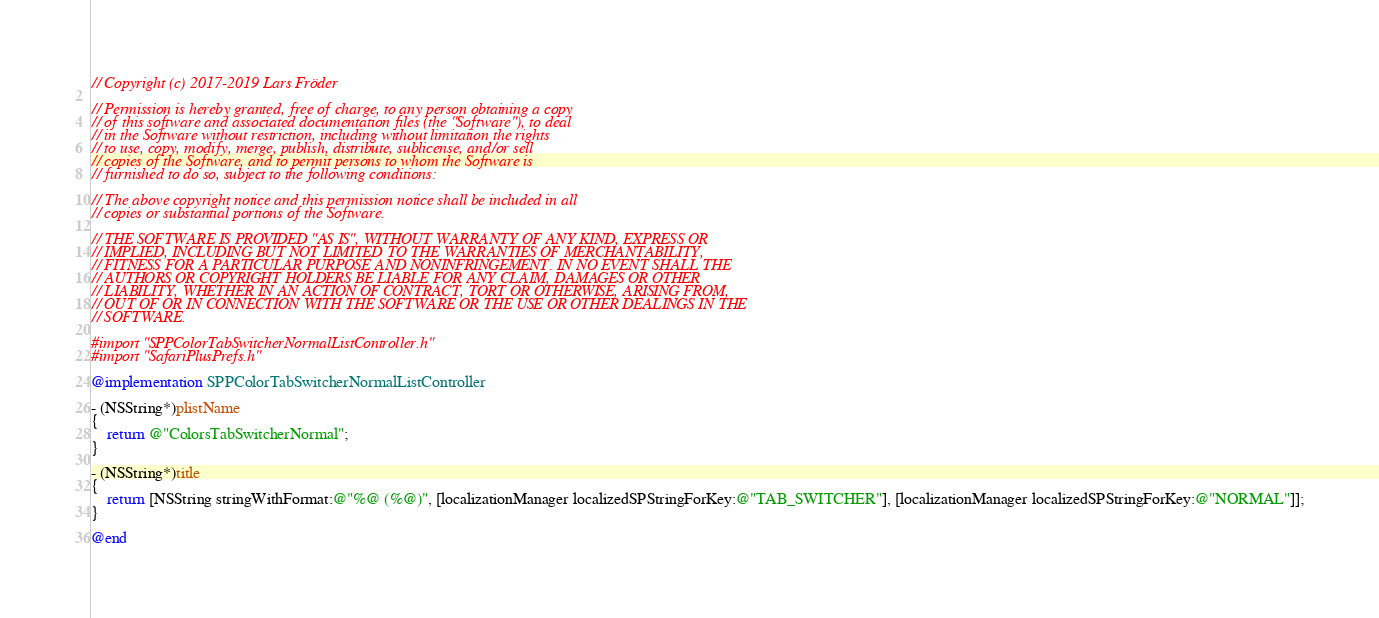Convert code to text. <code><loc_0><loc_0><loc_500><loc_500><_ObjectiveC_>// Copyright (c) 2017-2019 Lars Fröder

// Permission is hereby granted, free of charge, to any person obtaining a copy
// of this software and associated documentation files (the "Software"), to deal
// in the Software without restriction, including without limitation the rights
// to use, copy, modify, merge, publish, distribute, sublicense, and/or sell
// copies of the Software, and to permit persons to whom the Software is
// furnished to do so, subject to the following conditions:

// The above copyright notice and this permission notice shall be included in all
// copies or substantial portions of the Software.

// THE SOFTWARE IS PROVIDED "AS IS", WITHOUT WARRANTY OF ANY KIND, EXPRESS OR
// IMPLIED, INCLUDING BUT NOT LIMITED TO THE WARRANTIES OF MERCHANTABILITY,
// FITNESS FOR A PARTICULAR PURPOSE AND NONINFRINGEMENT. IN NO EVENT SHALL THE
// AUTHORS OR COPYRIGHT HOLDERS BE LIABLE FOR ANY CLAIM, DAMAGES OR OTHER
// LIABILITY, WHETHER IN AN ACTION OF CONTRACT, TORT OR OTHERWISE, ARISING FROM,
// OUT OF OR IN CONNECTION WITH THE SOFTWARE OR THE USE OR OTHER DEALINGS IN THE
// SOFTWARE.

#import "SPPColorTabSwitcherNormalListController.h"
#import "SafariPlusPrefs.h"

@implementation SPPColorTabSwitcherNormalListController

- (NSString*)plistName
{
	return @"ColorsTabSwitcherNormal";
}

- (NSString*)title
{
	return [NSString stringWithFormat:@"%@ (%@)", [localizationManager localizedSPStringForKey:@"TAB_SWITCHER"], [localizationManager localizedSPStringForKey:@"NORMAL"]];
}

@end
</code> 